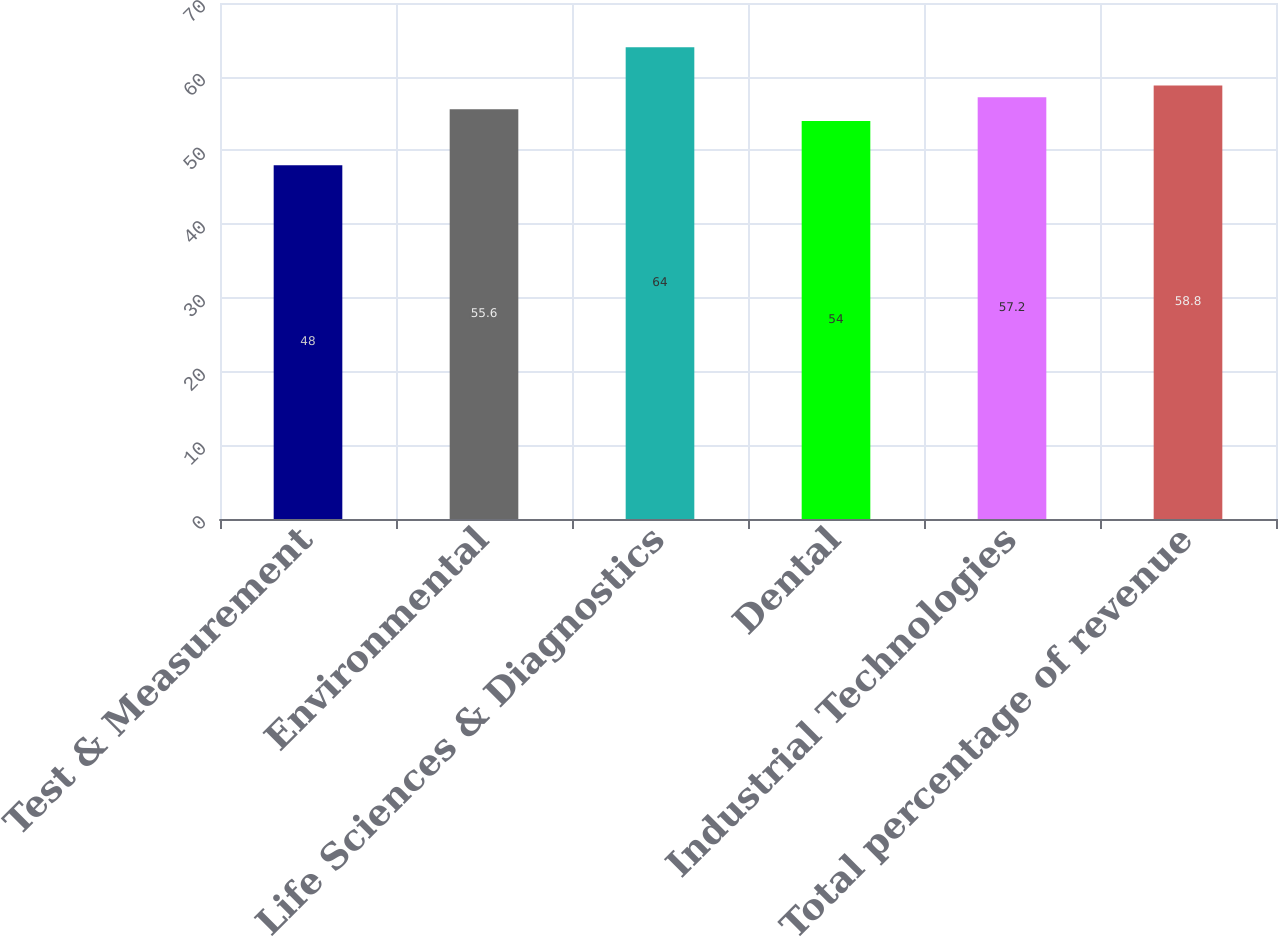Convert chart to OTSL. <chart><loc_0><loc_0><loc_500><loc_500><bar_chart><fcel>Test & Measurement<fcel>Environmental<fcel>Life Sciences & Diagnostics<fcel>Dental<fcel>Industrial Technologies<fcel>Total percentage of revenue<nl><fcel>48<fcel>55.6<fcel>64<fcel>54<fcel>57.2<fcel>58.8<nl></chart> 